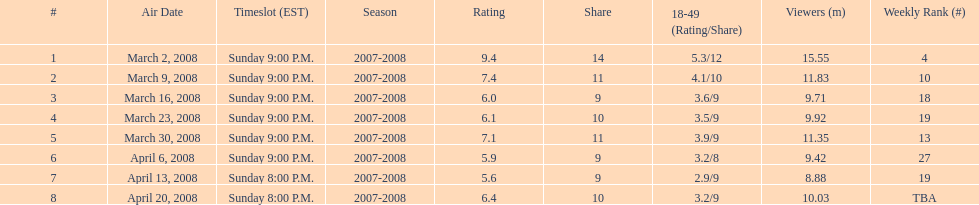Write the full table. {'header': ['#', 'Air Date', 'Timeslot (EST)', 'Season', 'Rating', 'Share', '18-49 (Rating/Share)', 'Viewers (m)', 'Weekly Rank (#)'], 'rows': [['1', 'March 2, 2008', 'Sunday 9:00 P.M.', '2007-2008', '9.4', '14', '5.3/12', '15.55', '4'], ['2', 'March 9, 2008', 'Sunday 9:00 P.M.', '2007-2008', '7.4', '11', '4.1/10', '11.83', '10'], ['3', 'March 16, 2008', 'Sunday 9:00 P.M.', '2007-2008', '6.0', '9', '3.6/9', '9.71', '18'], ['4', 'March 23, 2008', 'Sunday 9:00 P.M.', '2007-2008', '6.1', '10', '3.5/9', '9.92', '19'], ['5', 'March 30, 2008', 'Sunday 9:00 P.M.', '2007-2008', '7.1', '11', '3.9/9', '11.35', '13'], ['6', 'April 6, 2008', 'Sunday 9:00 P.M.', '2007-2008', '5.9', '9', '3.2/8', '9.42', '27'], ['7', 'April 13, 2008', 'Sunday 8:00 P.M.', '2007-2008', '5.6', '9', '2.9/9', '8.88', '19'], ['8', 'April 20, 2008', 'Sunday 8:00 P.M.', '2007-2008', '6.4', '10', '3.2/9', '10.03', 'TBA']]} Which program had the greatest rating? 1. 